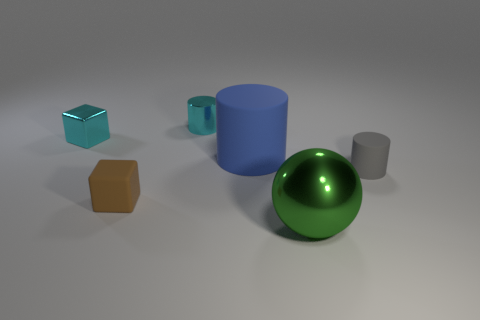The shiny block that is the same color as the tiny shiny cylinder is what size?
Offer a very short reply. Small. Are there any purple spheres made of the same material as the green sphere?
Offer a terse response. No. Does the tiny rubber thing that is on the left side of the blue cylinder have the same shape as the small thing that is behind the tiny shiny block?
Provide a short and direct response. No. Are there any small gray matte cylinders?
Offer a very short reply. Yes. There is a rubber cylinder that is the same size as the green metallic sphere; what color is it?
Give a very brief answer. Blue. What number of large blue rubber objects are the same shape as the large green object?
Provide a succinct answer. 0. Is the material of the small object right of the shiny sphere the same as the green thing?
Your response must be concise. No. How many blocks are rubber things or brown rubber things?
Offer a terse response. 1. The object to the left of the cube in front of the cube that is on the left side of the brown block is what shape?
Your response must be concise. Cube. The shiny object that is the same color as the small metal cube is what shape?
Keep it short and to the point. Cylinder. 